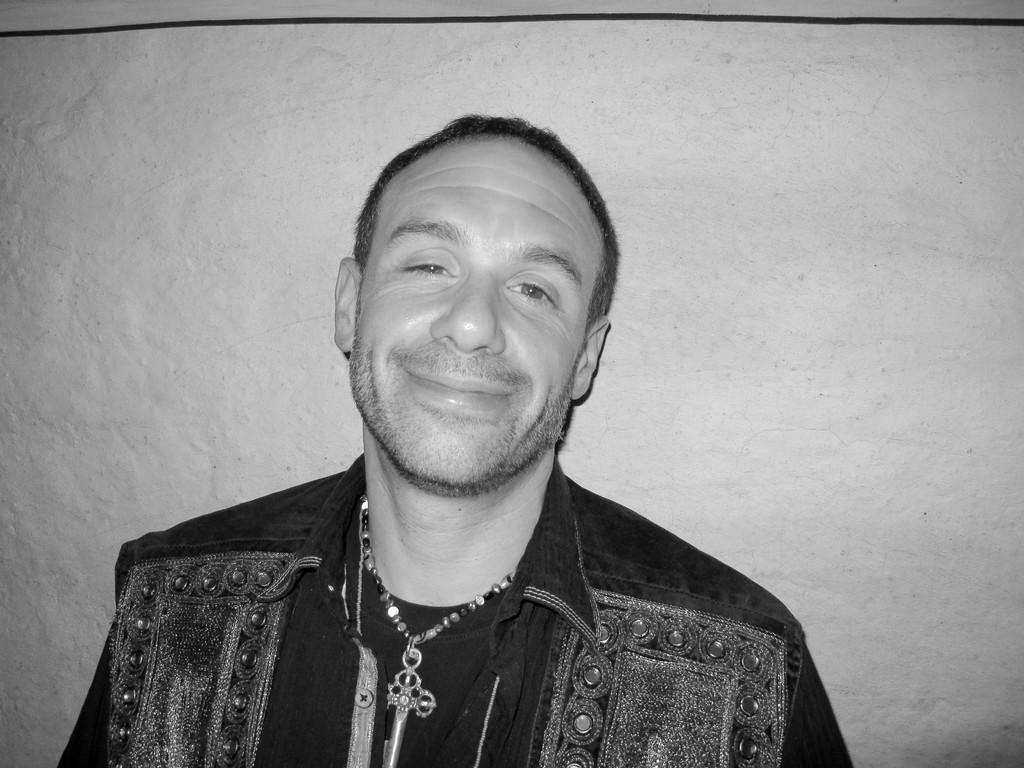What is the main subject of the image? There is a person in the image. What is the person wearing? The person is wearing a dress and a chain. What can be seen in the background of the image? There is a wall in the background of the image. How is the image presented in terms of color? The image is black and white. Can you see any clovers growing in the alley behind the person in the image? There is no alley or clover present in the image; it features a person in front of a wall in a black and white setting. 